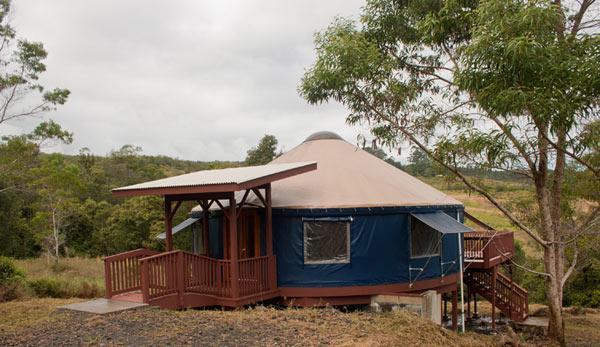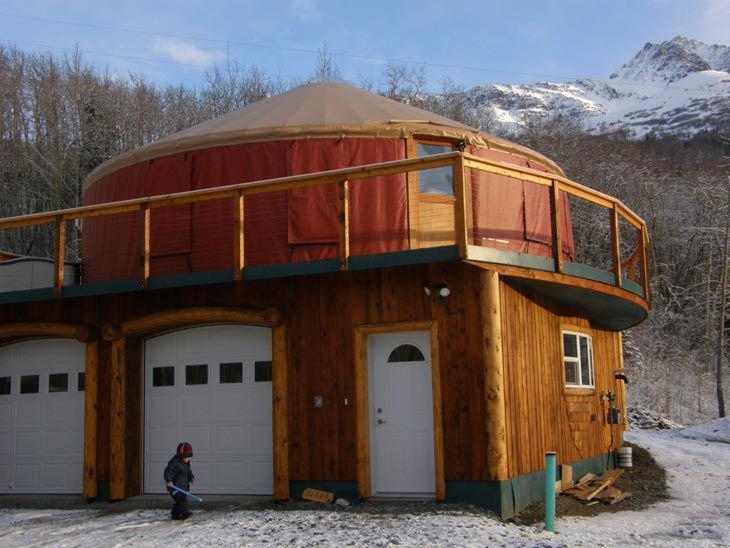The first image is the image on the left, the second image is the image on the right. Assess this claim about the two images: "An image shows a round house with a railing above two white garage doors.". Correct or not? Answer yes or no. Yes. 